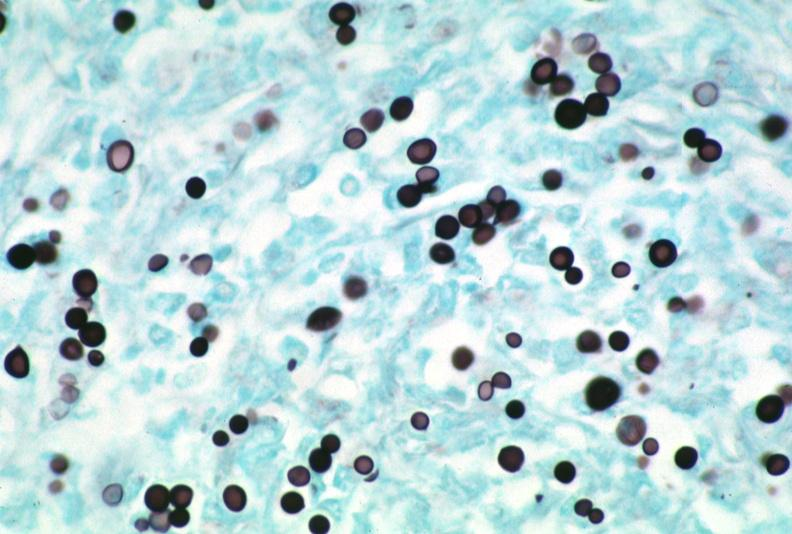does this image show lymph node, cryptococcosis gms?
Answer the question using a single word or phrase. Yes 